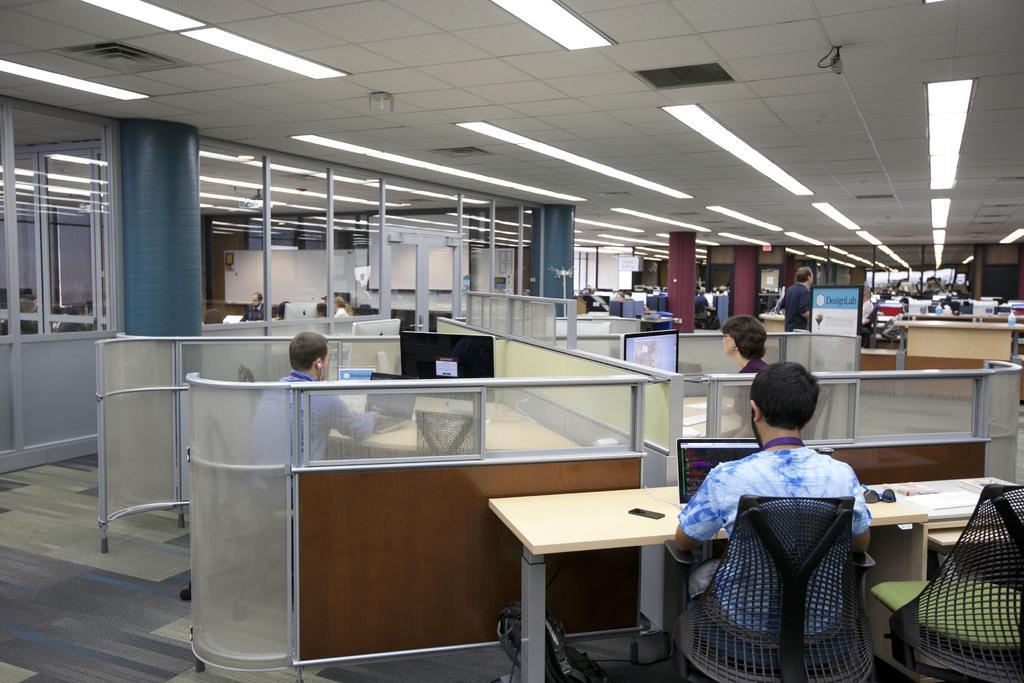In one or two sentences, can you explain what this image depicts? This image looks like a office in which the people are working on their desk in front of the desktop. At the top there is a ceiling and lights in between them. 